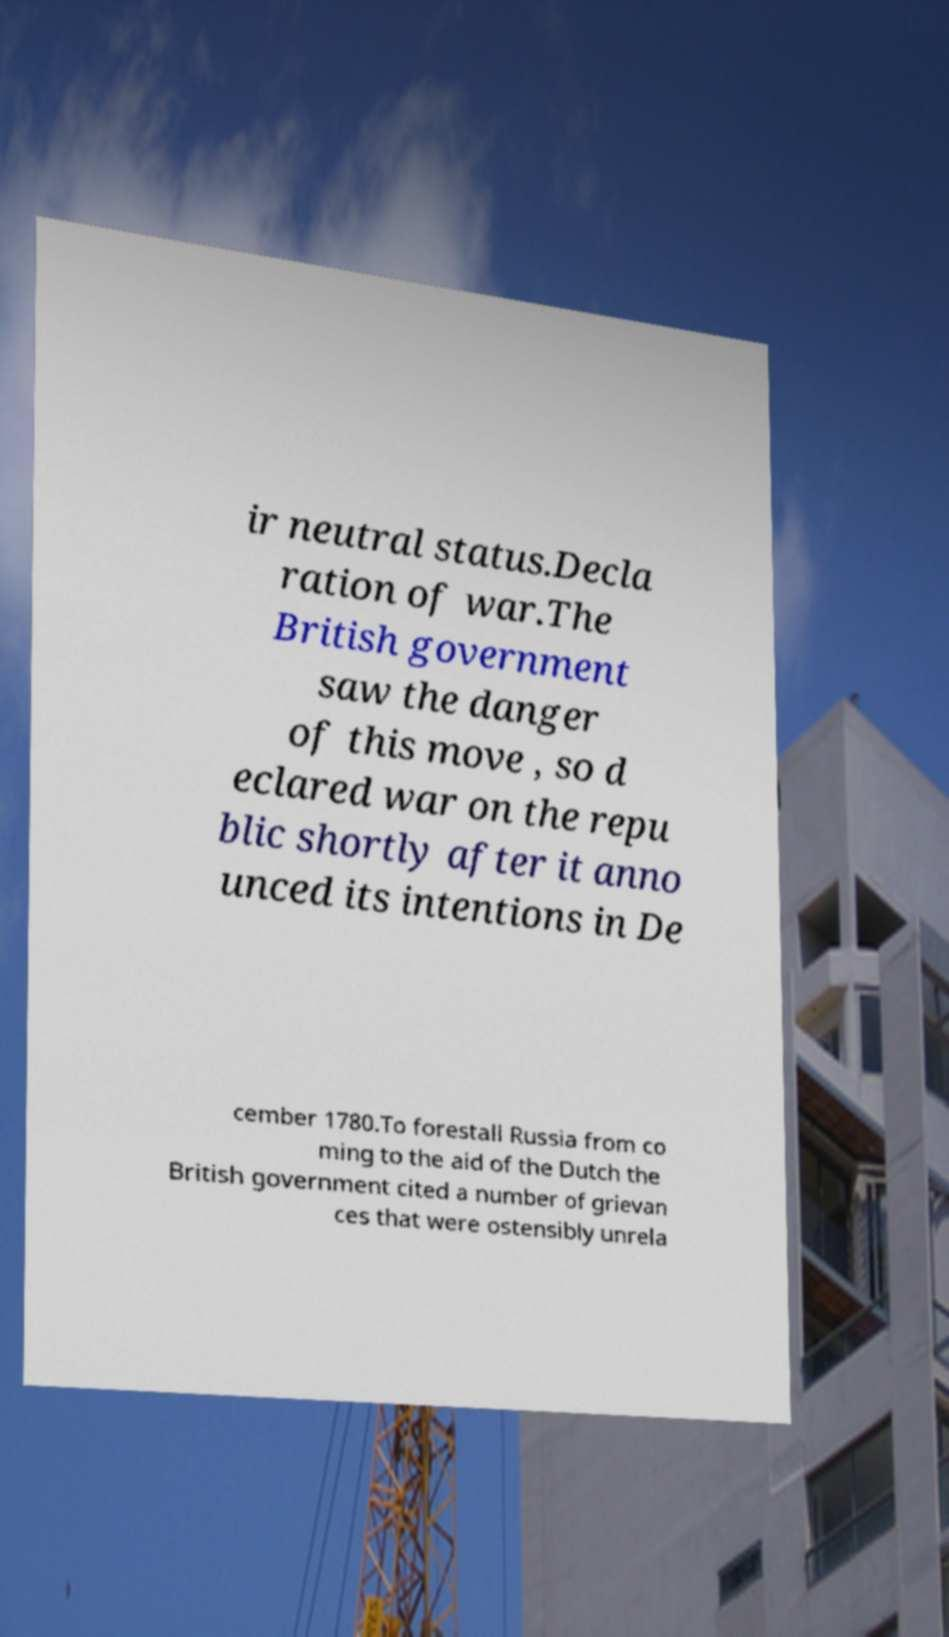Please identify and transcribe the text found in this image. ir neutral status.Decla ration of war.The British government saw the danger of this move , so d eclared war on the repu blic shortly after it anno unced its intentions in De cember 1780.To forestall Russia from co ming to the aid of the Dutch the British government cited a number of grievan ces that were ostensibly unrela 